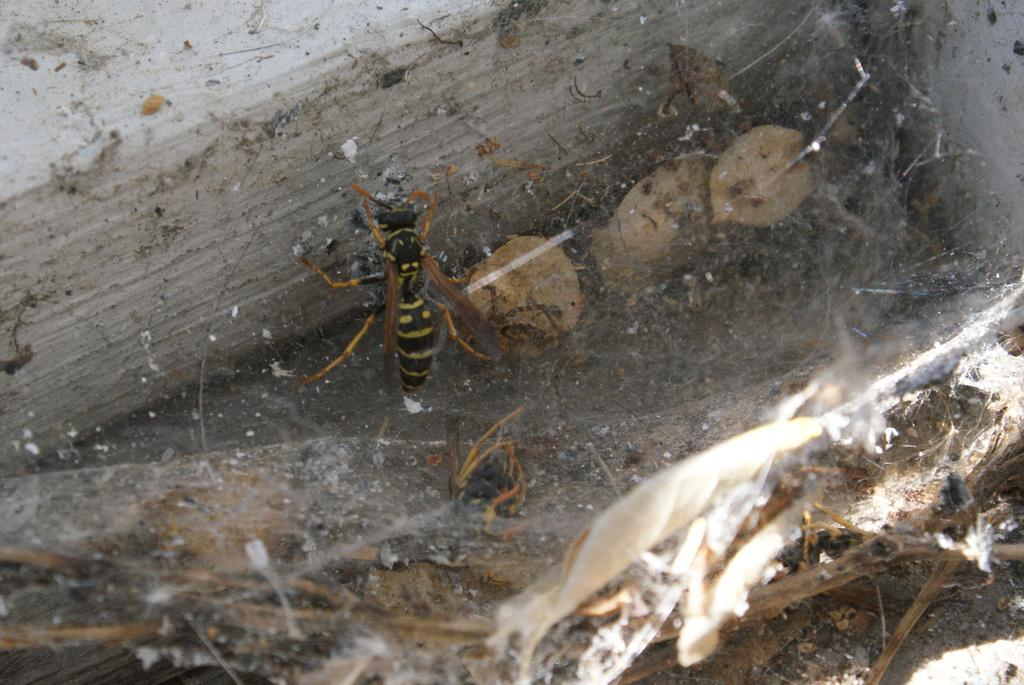What type of creature can be seen in the image? There is an insect in the image. What flavor of pear does the insect prefer in the image? There is no pear or indication of flavor preference in the image; it only features an insect. 